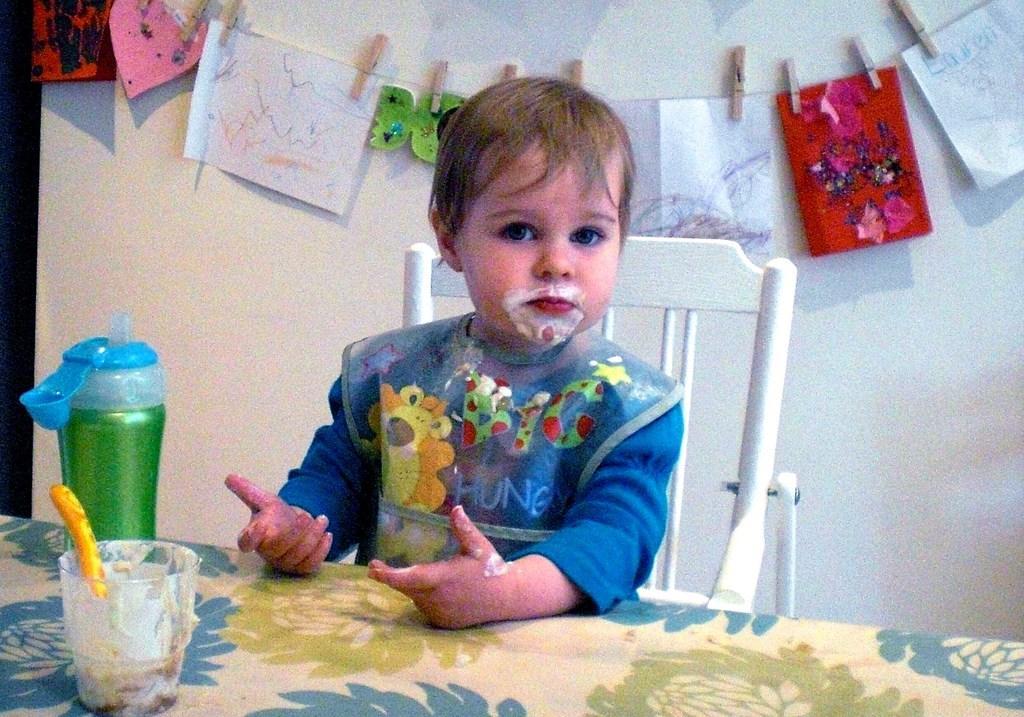Could you give a brief overview of what you see in this image? In this picture we can see a kid who is sitting on the chair. This is table. On the table there is a glass, and a bottle. On the background there is a wall and these are the posters. 